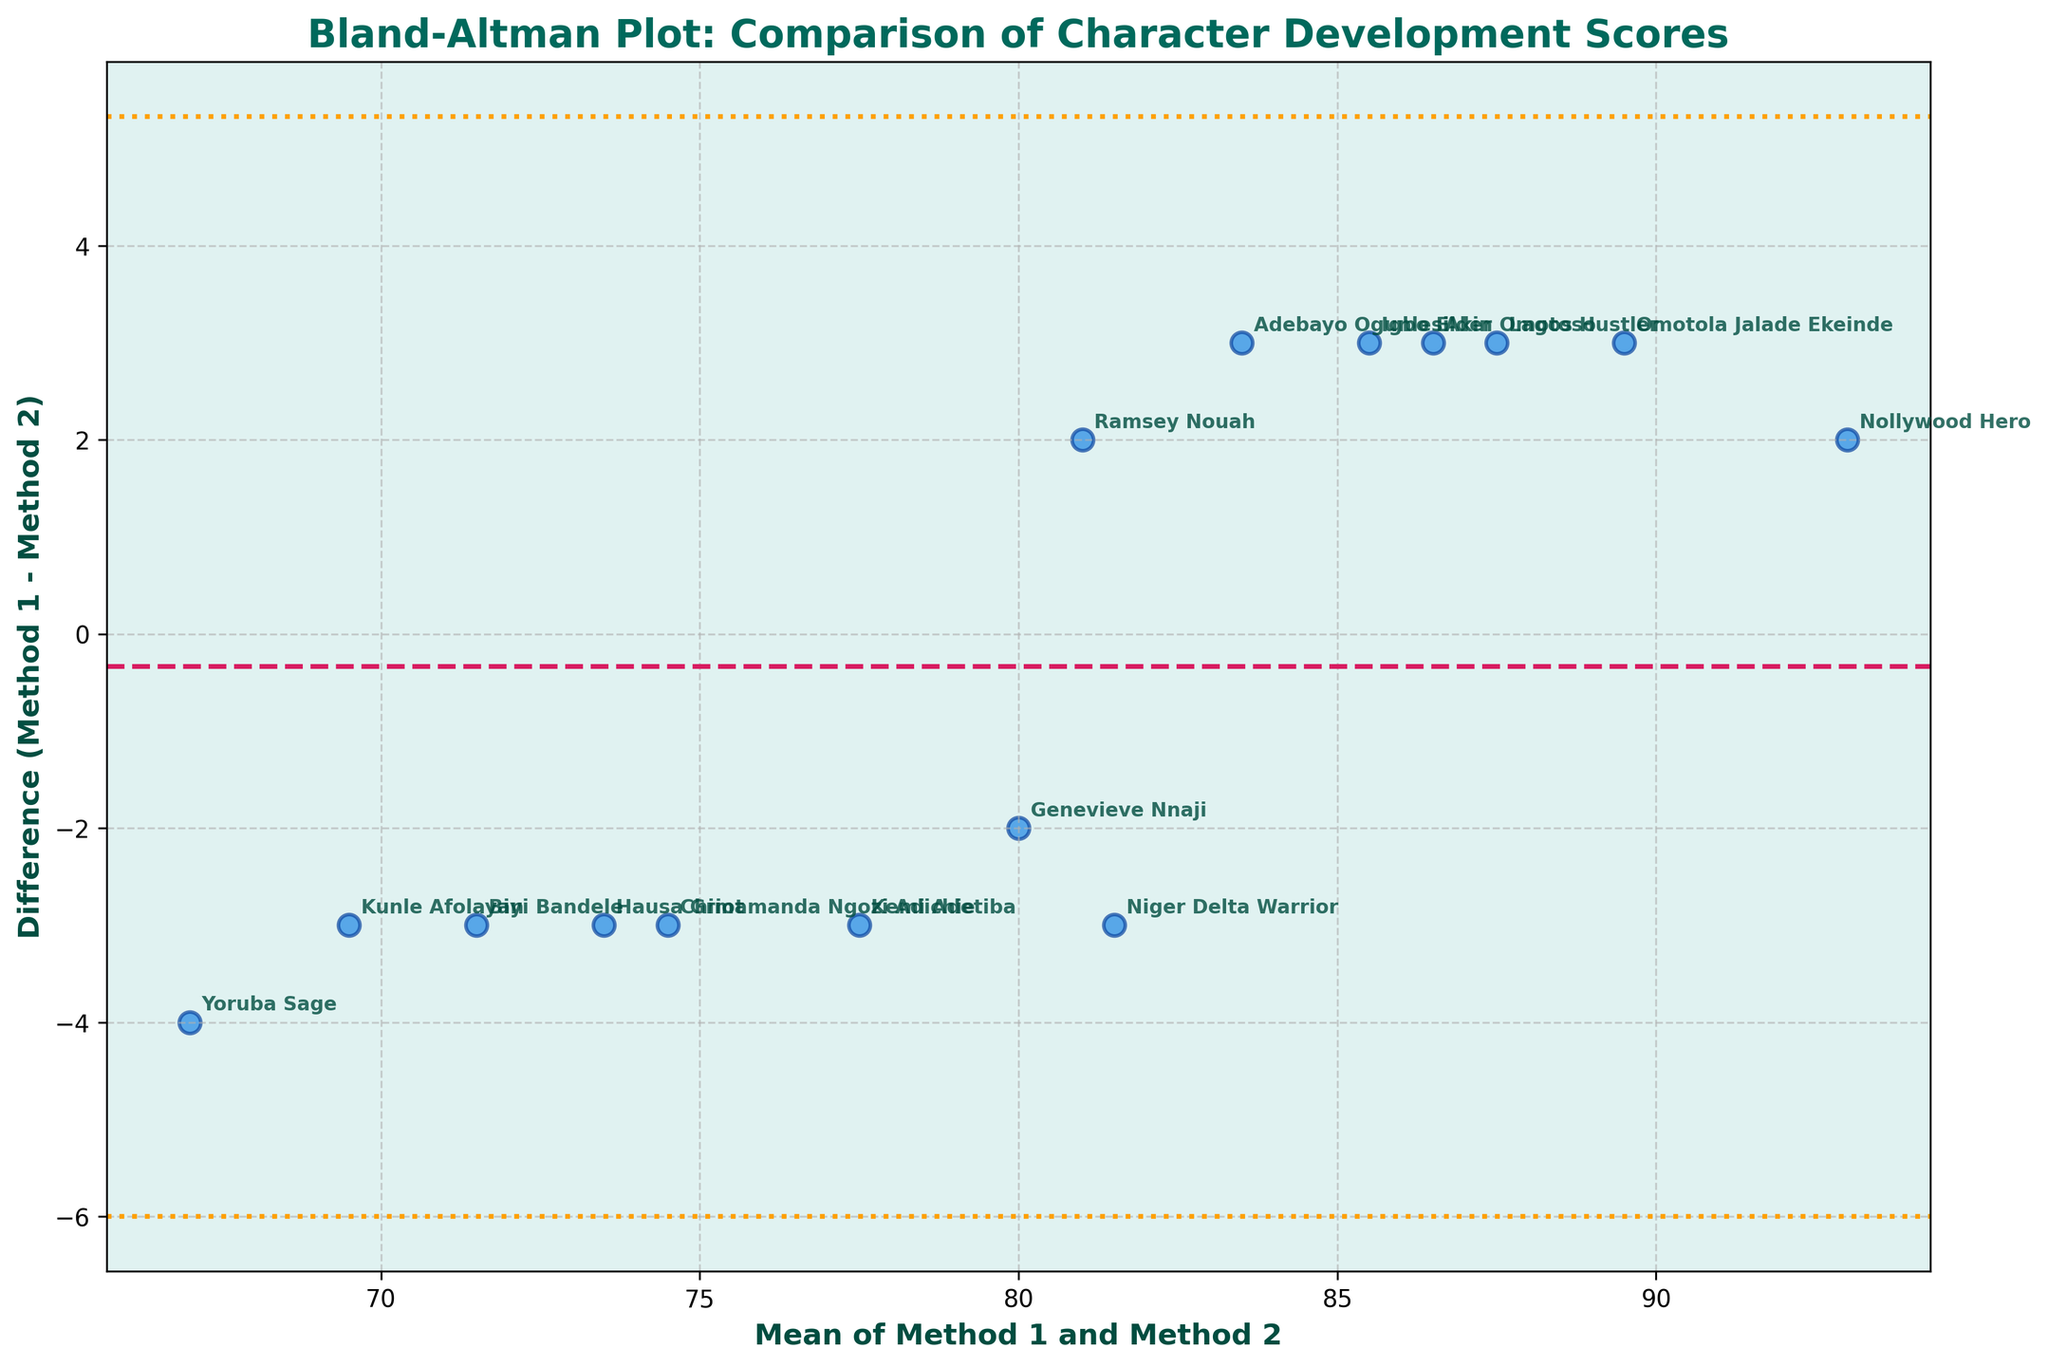What is the title of the Bland-Altman plot? The title is usually positioned at the top of the figure. In this plot, it clearly states the purpose of the visualization, which is the comparison of character development scores by two different script analysis methods.
Answer: Bland-Altman Plot: Comparison of Character Development Scores How many characters are being compared in the plot? Count the number of data points (each corresponding to a character) plotted on the figure. Each point represents a comparison of scores from Method 1 and Method 2 for a specific character. There are 15 data points labeled with character names.
Answer: 15 What are the labels on the X and Y axes? These labels are typically found along the horizontal and vertical edges of the plot. They describe what each axis represents, facilitating the interpretation of the data.
Answer: Mean of Method 1 and Method 2 (X), Difference (Method 1 - Method 2) (Y) Which character has the highest mean score? To determine this, locate the point furthest to the right along the x-axis, where the mean scores are higher. Identify the character associated with this point.
Answer: Nollywood Hero Is there a character whose scores from the two methods are identical? If so, who is it? Search for any data point that lies on the zero line of the y-axis, indicating no difference between scores given by Method 1 and Method 2. None of the points lie exactly on the zero line, suggesting no identical scores.
Answer: No How much is the average difference between the two methods? This is visually represented by the horizontal line passing through the data points derived from the mean difference of all data pairs. The value of this line represents the average difference.
Answer: Approximately -3 Which characters fall outside the limits of agreement? Identify the points that lie above or below the dashed lines representing the limits of agreement (mean difference ± 1.96 * standard deviation of the differences). These characters are outliers.
Answer: Nollywood Hero and Yoruba Sage How does Kunle Afolayan's difference score compare to Omotola Jalade Ekeinde's? Examine where these two characters fall on the y-axis (difference). Kunle Afolayan's score difference is less negative than Omotola Jalade Ekeinde's, meaning Method 1 scores Kunle Afolayan lower than Method 2 to a lesser extent.
Answer: Kunle Afolayan has a smaller negative difference Which character has the largest positive difference? Locate the point with the highest value on the y-axis where the difference is positive, indicating Method 1's score is higher than Method 2's score.
Answer: Niger Delta Warrior Are the differences between the scores mostly concentrated around the mean difference? Assess the distribution of the data points along the y-axis relative to the mean difference line. Most points near the mean difference suggest that the methods produce somewhat similar results. Yes, most differences cluster around the mean difference line.
Answer: Yes 